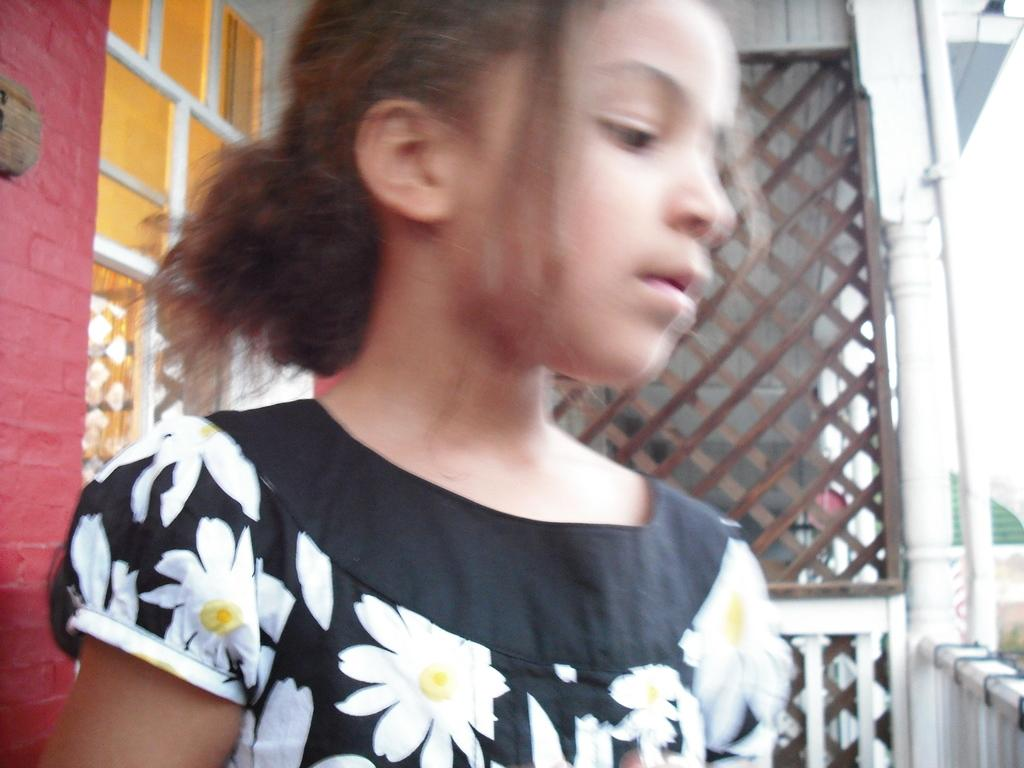Who is the main subject in the foreground of the picture? There is a girl in the foreground of the picture. What can be seen on the left side of the picture? There is a window and a wall on the left side of the picture. What is visible in the background of the picture? There is mesh visible in the background of the picture. What is happening on the right side of the picture? It is raining on the right side of the picture. What architectural feature is present on the right side of the picture? There is a pillar on the right side of the picture. What type of plastic is being stretched in the image? There is no plastic present in the image, nor is any stretching activity depicted. 